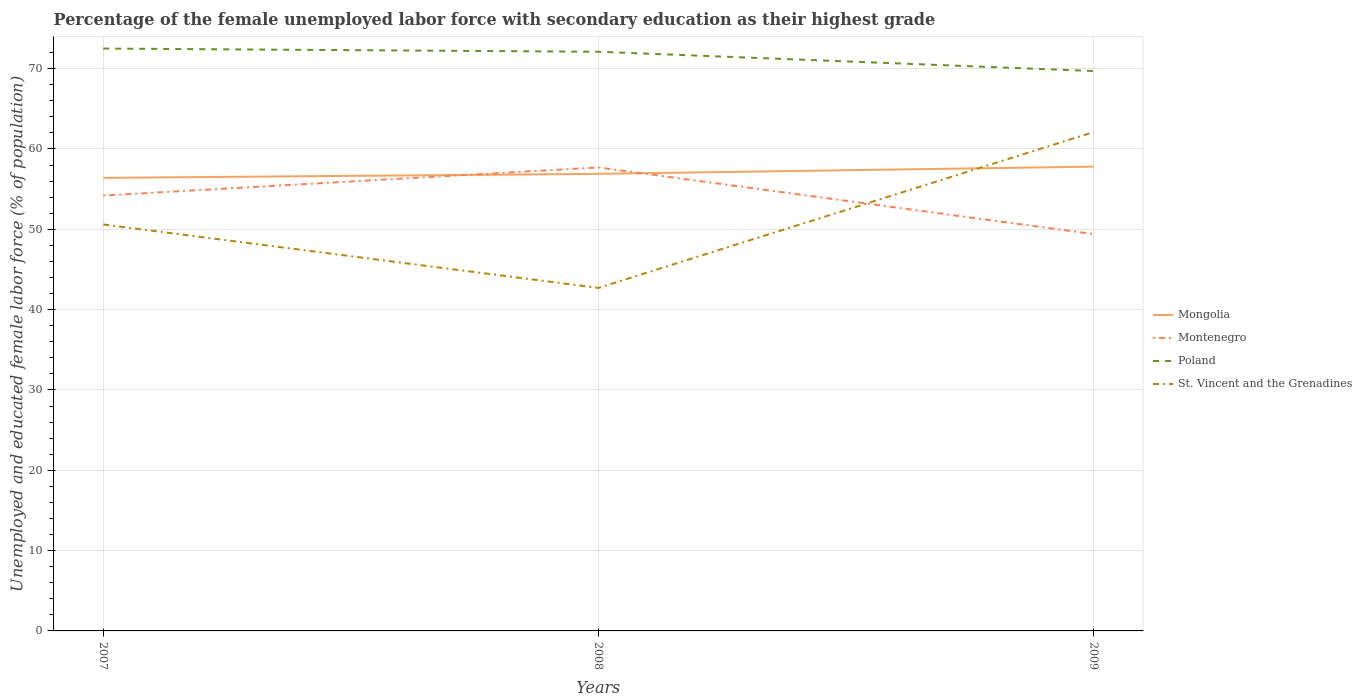Is the number of lines equal to the number of legend labels?
Offer a very short reply. Yes. Across all years, what is the maximum percentage of the unemployed female labor force with secondary education in Poland?
Give a very brief answer. 69.7. What is the total percentage of the unemployed female labor force with secondary education in Mongolia in the graph?
Offer a terse response. -1.4. What is the difference between the highest and the second highest percentage of the unemployed female labor force with secondary education in Mongolia?
Provide a succinct answer. 1.4. Is the percentage of the unemployed female labor force with secondary education in Poland strictly greater than the percentage of the unemployed female labor force with secondary education in Mongolia over the years?
Your response must be concise. No. What is the difference between two consecutive major ticks on the Y-axis?
Your answer should be compact. 10. Does the graph contain any zero values?
Provide a short and direct response. No. Where does the legend appear in the graph?
Ensure brevity in your answer.  Center right. What is the title of the graph?
Keep it short and to the point. Percentage of the female unemployed labor force with secondary education as their highest grade. What is the label or title of the X-axis?
Keep it short and to the point. Years. What is the label or title of the Y-axis?
Ensure brevity in your answer.  Unemployed and educated female labor force (% of population). What is the Unemployed and educated female labor force (% of population) in Mongolia in 2007?
Your answer should be compact. 56.4. What is the Unemployed and educated female labor force (% of population) in Montenegro in 2007?
Provide a succinct answer. 54.2. What is the Unemployed and educated female labor force (% of population) in Poland in 2007?
Your answer should be very brief. 72.5. What is the Unemployed and educated female labor force (% of population) in St. Vincent and the Grenadines in 2007?
Provide a succinct answer. 50.6. What is the Unemployed and educated female labor force (% of population) in Mongolia in 2008?
Your answer should be very brief. 56.9. What is the Unemployed and educated female labor force (% of population) in Montenegro in 2008?
Offer a very short reply. 57.7. What is the Unemployed and educated female labor force (% of population) of Poland in 2008?
Give a very brief answer. 72.1. What is the Unemployed and educated female labor force (% of population) of St. Vincent and the Grenadines in 2008?
Provide a succinct answer. 42.7. What is the Unemployed and educated female labor force (% of population) in Mongolia in 2009?
Your answer should be very brief. 57.8. What is the Unemployed and educated female labor force (% of population) of Montenegro in 2009?
Your answer should be compact. 49.4. What is the Unemployed and educated female labor force (% of population) of Poland in 2009?
Your answer should be very brief. 69.7. What is the Unemployed and educated female labor force (% of population) of St. Vincent and the Grenadines in 2009?
Your answer should be very brief. 62.1. Across all years, what is the maximum Unemployed and educated female labor force (% of population) of Mongolia?
Your answer should be very brief. 57.8. Across all years, what is the maximum Unemployed and educated female labor force (% of population) of Montenegro?
Ensure brevity in your answer.  57.7. Across all years, what is the maximum Unemployed and educated female labor force (% of population) of Poland?
Ensure brevity in your answer.  72.5. Across all years, what is the maximum Unemployed and educated female labor force (% of population) in St. Vincent and the Grenadines?
Offer a terse response. 62.1. Across all years, what is the minimum Unemployed and educated female labor force (% of population) of Mongolia?
Provide a succinct answer. 56.4. Across all years, what is the minimum Unemployed and educated female labor force (% of population) in Montenegro?
Give a very brief answer. 49.4. Across all years, what is the minimum Unemployed and educated female labor force (% of population) in Poland?
Provide a succinct answer. 69.7. Across all years, what is the minimum Unemployed and educated female labor force (% of population) of St. Vincent and the Grenadines?
Your answer should be very brief. 42.7. What is the total Unemployed and educated female labor force (% of population) in Mongolia in the graph?
Provide a succinct answer. 171.1. What is the total Unemployed and educated female labor force (% of population) of Montenegro in the graph?
Keep it short and to the point. 161.3. What is the total Unemployed and educated female labor force (% of population) of Poland in the graph?
Offer a very short reply. 214.3. What is the total Unemployed and educated female labor force (% of population) in St. Vincent and the Grenadines in the graph?
Provide a short and direct response. 155.4. What is the difference between the Unemployed and educated female labor force (% of population) of Montenegro in 2007 and that in 2008?
Provide a succinct answer. -3.5. What is the difference between the Unemployed and educated female labor force (% of population) in Montenegro in 2007 and that in 2009?
Your answer should be very brief. 4.8. What is the difference between the Unemployed and educated female labor force (% of population) of Poland in 2007 and that in 2009?
Offer a terse response. 2.8. What is the difference between the Unemployed and educated female labor force (% of population) of St. Vincent and the Grenadines in 2007 and that in 2009?
Your answer should be very brief. -11.5. What is the difference between the Unemployed and educated female labor force (% of population) in Montenegro in 2008 and that in 2009?
Keep it short and to the point. 8.3. What is the difference between the Unemployed and educated female labor force (% of population) of Poland in 2008 and that in 2009?
Keep it short and to the point. 2.4. What is the difference between the Unemployed and educated female labor force (% of population) of St. Vincent and the Grenadines in 2008 and that in 2009?
Provide a succinct answer. -19.4. What is the difference between the Unemployed and educated female labor force (% of population) in Mongolia in 2007 and the Unemployed and educated female labor force (% of population) in Montenegro in 2008?
Provide a short and direct response. -1.3. What is the difference between the Unemployed and educated female labor force (% of population) of Mongolia in 2007 and the Unemployed and educated female labor force (% of population) of Poland in 2008?
Keep it short and to the point. -15.7. What is the difference between the Unemployed and educated female labor force (% of population) in Montenegro in 2007 and the Unemployed and educated female labor force (% of population) in Poland in 2008?
Provide a succinct answer. -17.9. What is the difference between the Unemployed and educated female labor force (% of population) in Poland in 2007 and the Unemployed and educated female labor force (% of population) in St. Vincent and the Grenadines in 2008?
Offer a very short reply. 29.8. What is the difference between the Unemployed and educated female labor force (% of population) of Mongolia in 2007 and the Unemployed and educated female labor force (% of population) of Montenegro in 2009?
Your response must be concise. 7. What is the difference between the Unemployed and educated female labor force (% of population) of Mongolia in 2007 and the Unemployed and educated female labor force (% of population) of Poland in 2009?
Give a very brief answer. -13.3. What is the difference between the Unemployed and educated female labor force (% of population) of Mongolia in 2007 and the Unemployed and educated female labor force (% of population) of St. Vincent and the Grenadines in 2009?
Give a very brief answer. -5.7. What is the difference between the Unemployed and educated female labor force (% of population) of Montenegro in 2007 and the Unemployed and educated female labor force (% of population) of Poland in 2009?
Your answer should be very brief. -15.5. What is the difference between the Unemployed and educated female labor force (% of population) of Montenegro in 2007 and the Unemployed and educated female labor force (% of population) of St. Vincent and the Grenadines in 2009?
Your answer should be compact. -7.9. What is the difference between the Unemployed and educated female labor force (% of population) in Mongolia in 2008 and the Unemployed and educated female labor force (% of population) in St. Vincent and the Grenadines in 2009?
Ensure brevity in your answer.  -5.2. What is the difference between the Unemployed and educated female labor force (% of population) of Montenegro in 2008 and the Unemployed and educated female labor force (% of population) of Poland in 2009?
Provide a succinct answer. -12. What is the difference between the Unemployed and educated female labor force (% of population) in Montenegro in 2008 and the Unemployed and educated female labor force (% of population) in St. Vincent and the Grenadines in 2009?
Your answer should be very brief. -4.4. What is the difference between the Unemployed and educated female labor force (% of population) in Poland in 2008 and the Unemployed and educated female labor force (% of population) in St. Vincent and the Grenadines in 2009?
Provide a succinct answer. 10. What is the average Unemployed and educated female labor force (% of population) of Mongolia per year?
Your response must be concise. 57.03. What is the average Unemployed and educated female labor force (% of population) in Montenegro per year?
Keep it short and to the point. 53.77. What is the average Unemployed and educated female labor force (% of population) in Poland per year?
Your response must be concise. 71.43. What is the average Unemployed and educated female labor force (% of population) in St. Vincent and the Grenadines per year?
Your answer should be compact. 51.8. In the year 2007, what is the difference between the Unemployed and educated female labor force (% of population) in Mongolia and Unemployed and educated female labor force (% of population) in Montenegro?
Offer a terse response. 2.2. In the year 2007, what is the difference between the Unemployed and educated female labor force (% of population) in Mongolia and Unemployed and educated female labor force (% of population) in Poland?
Make the answer very short. -16.1. In the year 2007, what is the difference between the Unemployed and educated female labor force (% of population) in Mongolia and Unemployed and educated female labor force (% of population) in St. Vincent and the Grenadines?
Make the answer very short. 5.8. In the year 2007, what is the difference between the Unemployed and educated female labor force (% of population) in Montenegro and Unemployed and educated female labor force (% of population) in Poland?
Your response must be concise. -18.3. In the year 2007, what is the difference between the Unemployed and educated female labor force (% of population) in Poland and Unemployed and educated female labor force (% of population) in St. Vincent and the Grenadines?
Provide a short and direct response. 21.9. In the year 2008, what is the difference between the Unemployed and educated female labor force (% of population) in Mongolia and Unemployed and educated female labor force (% of population) in Montenegro?
Provide a short and direct response. -0.8. In the year 2008, what is the difference between the Unemployed and educated female labor force (% of population) of Mongolia and Unemployed and educated female labor force (% of population) of Poland?
Make the answer very short. -15.2. In the year 2008, what is the difference between the Unemployed and educated female labor force (% of population) in Montenegro and Unemployed and educated female labor force (% of population) in Poland?
Keep it short and to the point. -14.4. In the year 2008, what is the difference between the Unemployed and educated female labor force (% of population) in Poland and Unemployed and educated female labor force (% of population) in St. Vincent and the Grenadines?
Offer a terse response. 29.4. In the year 2009, what is the difference between the Unemployed and educated female labor force (% of population) of Montenegro and Unemployed and educated female labor force (% of population) of Poland?
Keep it short and to the point. -20.3. In the year 2009, what is the difference between the Unemployed and educated female labor force (% of population) of Poland and Unemployed and educated female labor force (% of population) of St. Vincent and the Grenadines?
Your answer should be very brief. 7.6. What is the ratio of the Unemployed and educated female labor force (% of population) in Mongolia in 2007 to that in 2008?
Provide a short and direct response. 0.99. What is the ratio of the Unemployed and educated female labor force (% of population) in Montenegro in 2007 to that in 2008?
Keep it short and to the point. 0.94. What is the ratio of the Unemployed and educated female labor force (% of population) in Poland in 2007 to that in 2008?
Your answer should be compact. 1.01. What is the ratio of the Unemployed and educated female labor force (% of population) in St. Vincent and the Grenadines in 2007 to that in 2008?
Your answer should be very brief. 1.19. What is the ratio of the Unemployed and educated female labor force (% of population) of Mongolia in 2007 to that in 2009?
Offer a terse response. 0.98. What is the ratio of the Unemployed and educated female labor force (% of population) in Montenegro in 2007 to that in 2009?
Provide a short and direct response. 1.1. What is the ratio of the Unemployed and educated female labor force (% of population) of Poland in 2007 to that in 2009?
Make the answer very short. 1.04. What is the ratio of the Unemployed and educated female labor force (% of population) of St. Vincent and the Grenadines in 2007 to that in 2009?
Your answer should be very brief. 0.81. What is the ratio of the Unemployed and educated female labor force (% of population) of Mongolia in 2008 to that in 2009?
Provide a succinct answer. 0.98. What is the ratio of the Unemployed and educated female labor force (% of population) of Montenegro in 2008 to that in 2009?
Your answer should be compact. 1.17. What is the ratio of the Unemployed and educated female labor force (% of population) of Poland in 2008 to that in 2009?
Give a very brief answer. 1.03. What is the ratio of the Unemployed and educated female labor force (% of population) in St. Vincent and the Grenadines in 2008 to that in 2009?
Offer a very short reply. 0.69. What is the difference between the highest and the second highest Unemployed and educated female labor force (% of population) in Mongolia?
Provide a succinct answer. 0.9. What is the difference between the highest and the second highest Unemployed and educated female labor force (% of population) of Montenegro?
Your answer should be compact. 3.5. What is the difference between the highest and the second highest Unemployed and educated female labor force (% of population) of Poland?
Keep it short and to the point. 0.4. What is the difference between the highest and the second highest Unemployed and educated female labor force (% of population) in St. Vincent and the Grenadines?
Keep it short and to the point. 11.5. What is the difference between the highest and the lowest Unemployed and educated female labor force (% of population) in Poland?
Offer a very short reply. 2.8. What is the difference between the highest and the lowest Unemployed and educated female labor force (% of population) in St. Vincent and the Grenadines?
Your answer should be compact. 19.4. 